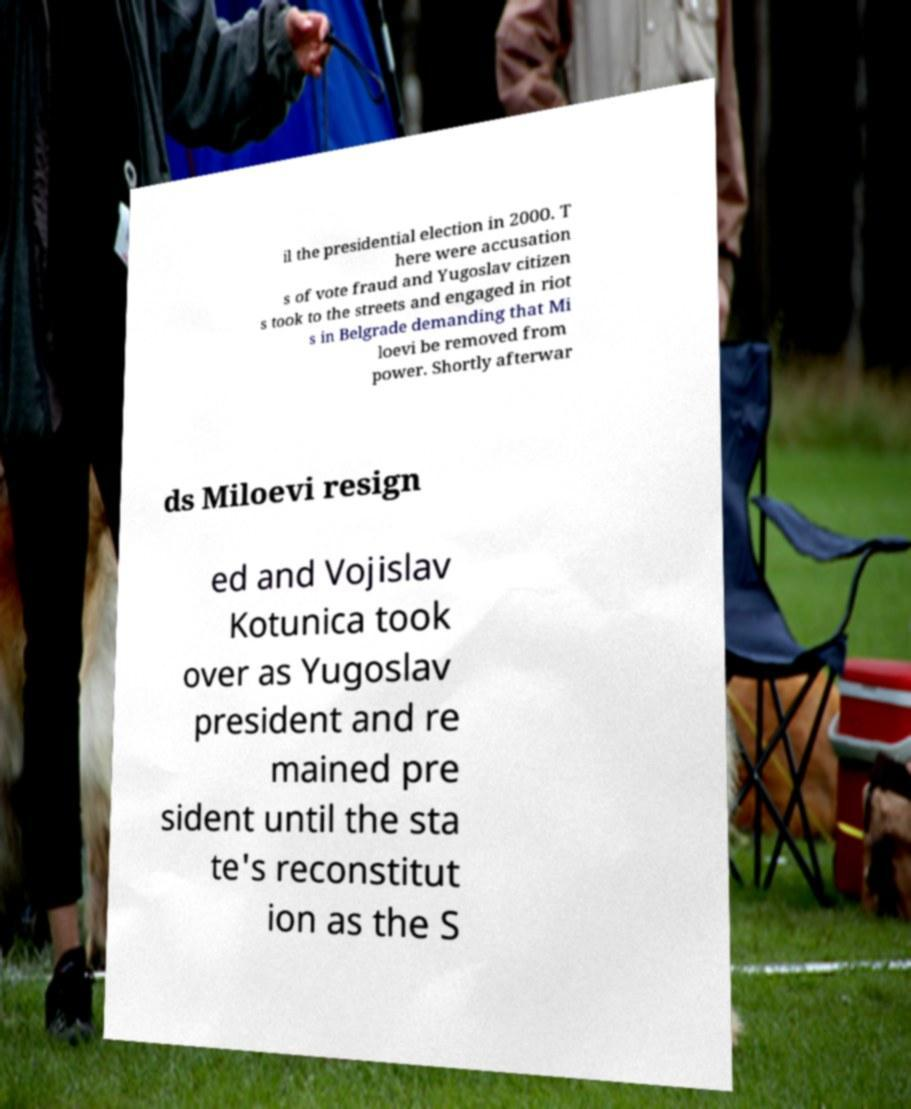Please read and relay the text visible in this image. What does it say? il the presidential election in 2000. T here were accusation s of vote fraud and Yugoslav citizen s took to the streets and engaged in riot s in Belgrade demanding that Mi loevi be removed from power. Shortly afterwar ds Miloevi resign ed and Vojislav Kotunica took over as Yugoslav president and re mained pre sident until the sta te's reconstitut ion as the S 